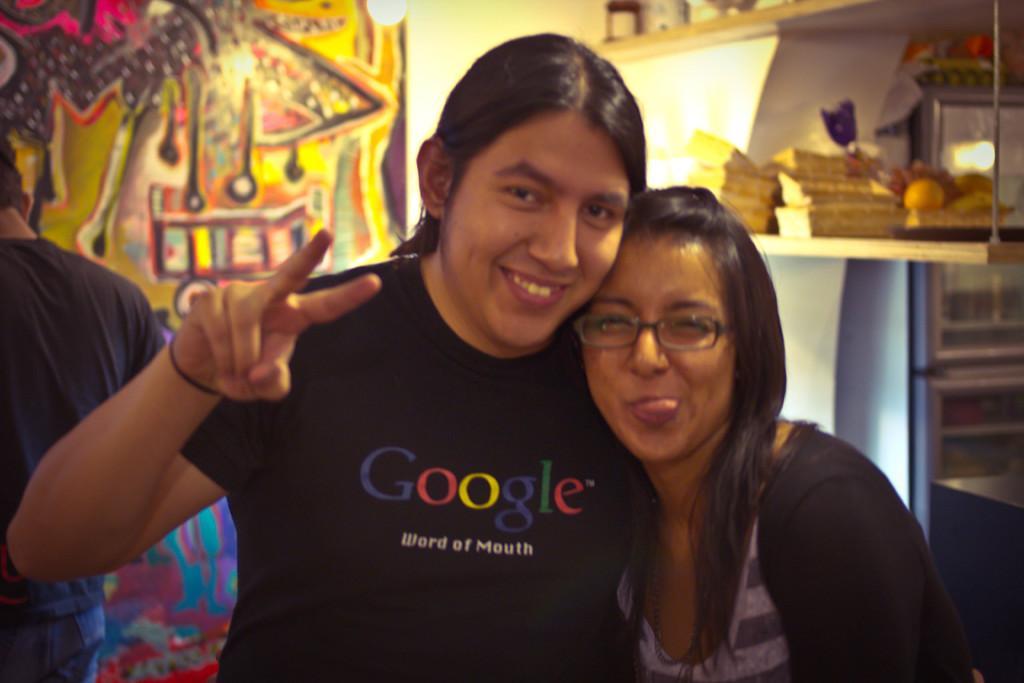Could you give a brief overview of what you see in this image? In this image I can see two persons, the person at left is wearing black color shirt. In the background I can see few objects on the wooden surface and I can see the colorful wall and the light. 